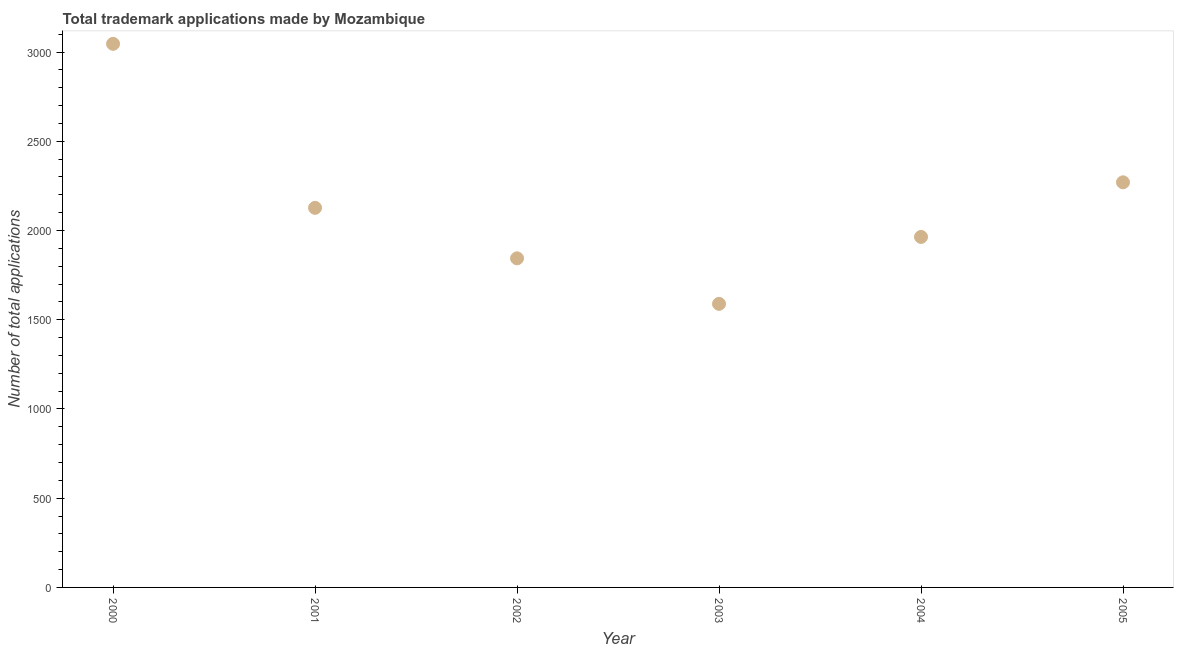What is the number of trademark applications in 2002?
Your answer should be compact. 1844. Across all years, what is the maximum number of trademark applications?
Your answer should be compact. 3046. Across all years, what is the minimum number of trademark applications?
Provide a succinct answer. 1589. What is the sum of the number of trademark applications?
Your response must be concise. 1.28e+04. What is the difference between the number of trademark applications in 2002 and 2003?
Provide a succinct answer. 255. What is the average number of trademark applications per year?
Make the answer very short. 2140. What is the median number of trademark applications?
Offer a terse response. 2045.5. In how many years, is the number of trademark applications greater than 1100 ?
Offer a very short reply. 6. What is the ratio of the number of trademark applications in 2001 to that in 2002?
Offer a terse response. 1.15. What is the difference between the highest and the second highest number of trademark applications?
Offer a terse response. 776. What is the difference between the highest and the lowest number of trademark applications?
Keep it short and to the point. 1457. Does the number of trademark applications monotonically increase over the years?
Your answer should be very brief. No. How many dotlines are there?
Offer a terse response. 1. How many years are there in the graph?
Provide a succinct answer. 6. Are the values on the major ticks of Y-axis written in scientific E-notation?
Ensure brevity in your answer.  No. Does the graph contain any zero values?
Your answer should be compact. No. Does the graph contain grids?
Ensure brevity in your answer.  No. What is the title of the graph?
Offer a very short reply. Total trademark applications made by Mozambique. What is the label or title of the Y-axis?
Your answer should be compact. Number of total applications. What is the Number of total applications in 2000?
Make the answer very short. 3046. What is the Number of total applications in 2001?
Provide a succinct answer. 2127. What is the Number of total applications in 2002?
Your answer should be very brief. 1844. What is the Number of total applications in 2003?
Your response must be concise. 1589. What is the Number of total applications in 2004?
Ensure brevity in your answer.  1964. What is the Number of total applications in 2005?
Make the answer very short. 2270. What is the difference between the Number of total applications in 2000 and 2001?
Your response must be concise. 919. What is the difference between the Number of total applications in 2000 and 2002?
Your answer should be very brief. 1202. What is the difference between the Number of total applications in 2000 and 2003?
Ensure brevity in your answer.  1457. What is the difference between the Number of total applications in 2000 and 2004?
Keep it short and to the point. 1082. What is the difference between the Number of total applications in 2000 and 2005?
Make the answer very short. 776. What is the difference between the Number of total applications in 2001 and 2002?
Provide a short and direct response. 283. What is the difference between the Number of total applications in 2001 and 2003?
Provide a succinct answer. 538. What is the difference between the Number of total applications in 2001 and 2004?
Your response must be concise. 163. What is the difference between the Number of total applications in 2001 and 2005?
Your response must be concise. -143. What is the difference between the Number of total applications in 2002 and 2003?
Keep it short and to the point. 255. What is the difference between the Number of total applications in 2002 and 2004?
Your answer should be very brief. -120. What is the difference between the Number of total applications in 2002 and 2005?
Your answer should be very brief. -426. What is the difference between the Number of total applications in 2003 and 2004?
Your response must be concise. -375. What is the difference between the Number of total applications in 2003 and 2005?
Your response must be concise. -681. What is the difference between the Number of total applications in 2004 and 2005?
Your response must be concise. -306. What is the ratio of the Number of total applications in 2000 to that in 2001?
Offer a very short reply. 1.43. What is the ratio of the Number of total applications in 2000 to that in 2002?
Offer a very short reply. 1.65. What is the ratio of the Number of total applications in 2000 to that in 2003?
Give a very brief answer. 1.92. What is the ratio of the Number of total applications in 2000 to that in 2004?
Make the answer very short. 1.55. What is the ratio of the Number of total applications in 2000 to that in 2005?
Your response must be concise. 1.34. What is the ratio of the Number of total applications in 2001 to that in 2002?
Provide a short and direct response. 1.15. What is the ratio of the Number of total applications in 2001 to that in 2003?
Ensure brevity in your answer.  1.34. What is the ratio of the Number of total applications in 2001 to that in 2004?
Give a very brief answer. 1.08. What is the ratio of the Number of total applications in 2001 to that in 2005?
Keep it short and to the point. 0.94. What is the ratio of the Number of total applications in 2002 to that in 2003?
Your answer should be very brief. 1.16. What is the ratio of the Number of total applications in 2002 to that in 2004?
Your response must be concise. 0.94. What is the ratio of the Number of total applications in 2002 to that in 2005?
Offer a very short reply. 0.81. What is the ratio of the Number of total applications in 2003 to that in 2004?
Make the answer very short. 0.81. What is the ratio of the Number of total applications in 2004 to that in 2005?
Your answer should be compact. 0.86. 